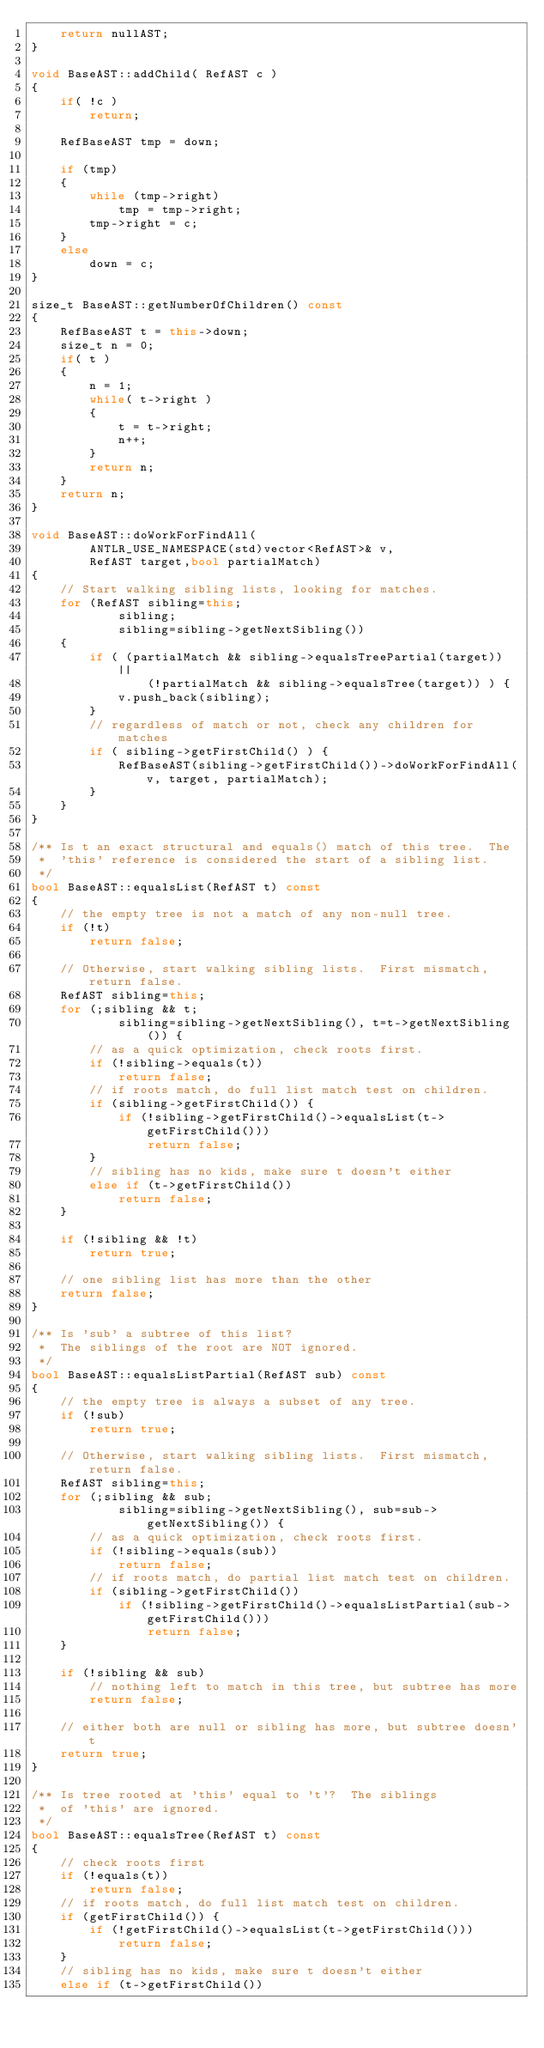<code> <loc_0><loc_0><loc_500><loc_500><_C++_>	return nullAST;
}

void BaseAST::addChild( RefAST c )
{
	if( !c )
		return;

	RefBaseAST tmp = down;

	if (tmp)
	{
		while (tmp->right)
			tmp = tmp->right;
		tmp->right = c;
	}
	else
		down = c;
}

size_t BaseAST::getNumberOfChildren() const
{
	RefBaseAST t = this->down;
	size_t n = 0;
	if( t )
	{
		n = 1;
		while( t->right )
		{
			t = t->right;
			n++;
		}
		return n;
	}
	return n;
}

void BaseAST::doWorkForFindAll(
		ANTLR_USE_NAMESPACE(std)vector<RefAST>& v,
		RefAST target,bool partialMatch)
{
	// Start walking sibling lists, looking for matches.
	for (RefAST sibling=this;
			sibling;
			sibling=sibling->getNextSibling())
	{
		if ( (partialMatch && sibling->equalsTreePartial(target)) ||
				(!partialMatch && sibling->equalsTree(target)) ) {
			v.push_back(sibling);
		}
		// regardless of match or not, check any children for matches
		if ( sibling->getFirstChild() ) {
			RefBaseAST(sibling->getFirstChild())->doWorkForFindAll(v, target, partialMatch);
		}
	}
}

/** Is t an exact structural and equals() match of this tree.  The
 *  'this' reference is considered the start of a sibling list.
 */
bool BaseAST::equalsList(RefAST t) const
{
	// the empty tree is not a match of any non-null tree.
	if (!t)
		return false;

	// Otherwise, start walking sibling lists.  First mismatch, return false.
	RefAST sibling=this;
	for (;sibling && t;
			sibling=sibling->getNextSibling(), t=t->getNextSibling()) {
		// as a quick optimization, check roots first.
		if (!sibling->equals(t))
			return false;
		// if roots match, do full list match test on children.
		if (sibling->getFirstChild()) {
			if (!sibling->getFirstChild()->equalsList(t->getFirstChild()))
				return false;
		}
		// sibling has no kids, make sure t doesn't either
		else if (t->getFirstChild())
			return false;
	}

	if (!sibling && !t)
		return true;

	// one sibling list has more than the other
	return false;
}

/** Is 'sub' a subtree of this list?
 *  The siblings of the root are NOT ignored.
 */
bool BaseAST::equalsListPartial(RefAST sub) const
{
	// the empty tree is always a subset of any tree.
	if (!sub)
		return true;

	// Otherwise, start walking sibling lists.  First mismatch, return false.
	RefAST sibling=this;
	for (;sibling && sub;
			sibling=sibling->getNextSibling(), sub=sub->getNextSibling()) {
		// as a quick optimization, check roots first.
		if (!sibling->equals(sub))
			return false;
		// if roots match, do partial list match test on children.
		if (sibling->getFirstChild())
			if (!sibling->getFirstChild()->equalsListPartial(sub->getFirstChild()))
				return false;
	}

	if (!sibling && sub)
		// nothing left to match in this tree, but subtree has more
		return false;

	// either both are null or sibling has more, but subtree doesn't
	return true;
}

/** Is tree rooted at 'this' equal to 't'?  The siblings
 *  of 'this' are ignored.
 */
bool BaseAST::equalsTree(RefAST t) const
{
	// check roots first
	if (!equals(t))
		return false;
	// if roots match, do full list match test on children.
	if (getFirstChild()) {
		if (!getFirstChild()->equalsList(t->getFirstChild()))
			return false;
	}
	// sibling has no kids, make sure t doesn't either
	else if (t->getFirstChild())</code> 